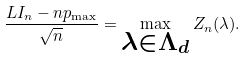Convert formula to latex. <formula><loc_0><loc_0><loc_500><loc_500>\frac { L I _ { n } - n p _ { \max } } { \sqrt { n } } = \max _ { \substack { \lambda \in \Lambda _ { d } } } Z _ { n } ( \lambda ) .</formula> 